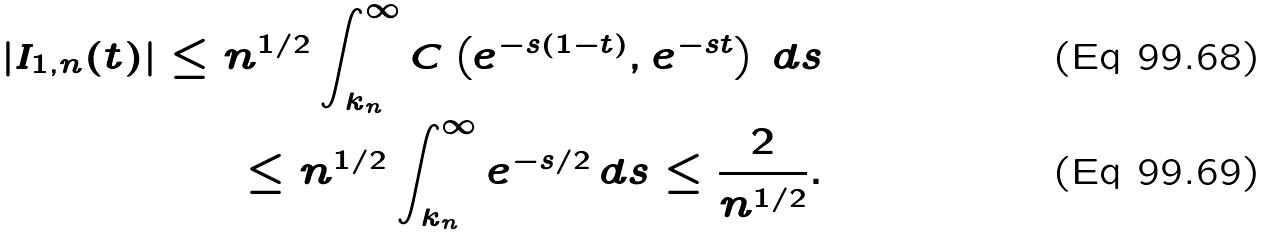Convert formula to latex. <formula><loc_0><loc_0><loc_500><loc_500>| I _ { 1 , n } ( t ) | \leq n ^ { 1 / 2 } \int _ { k _ { n } } ^ { \infty } C \left ( e ^ { - s ( 1 - t ) } , e ^ { - s t } \right ) \, d s \\ \leq n ^ { 1 / 2 } \int _ { k _ { n } } ^ { \infty } e ^ { - s / 2 } \, d s \leq \frac { 2 } { n ^ { 1 / 2 } } .</formula> 